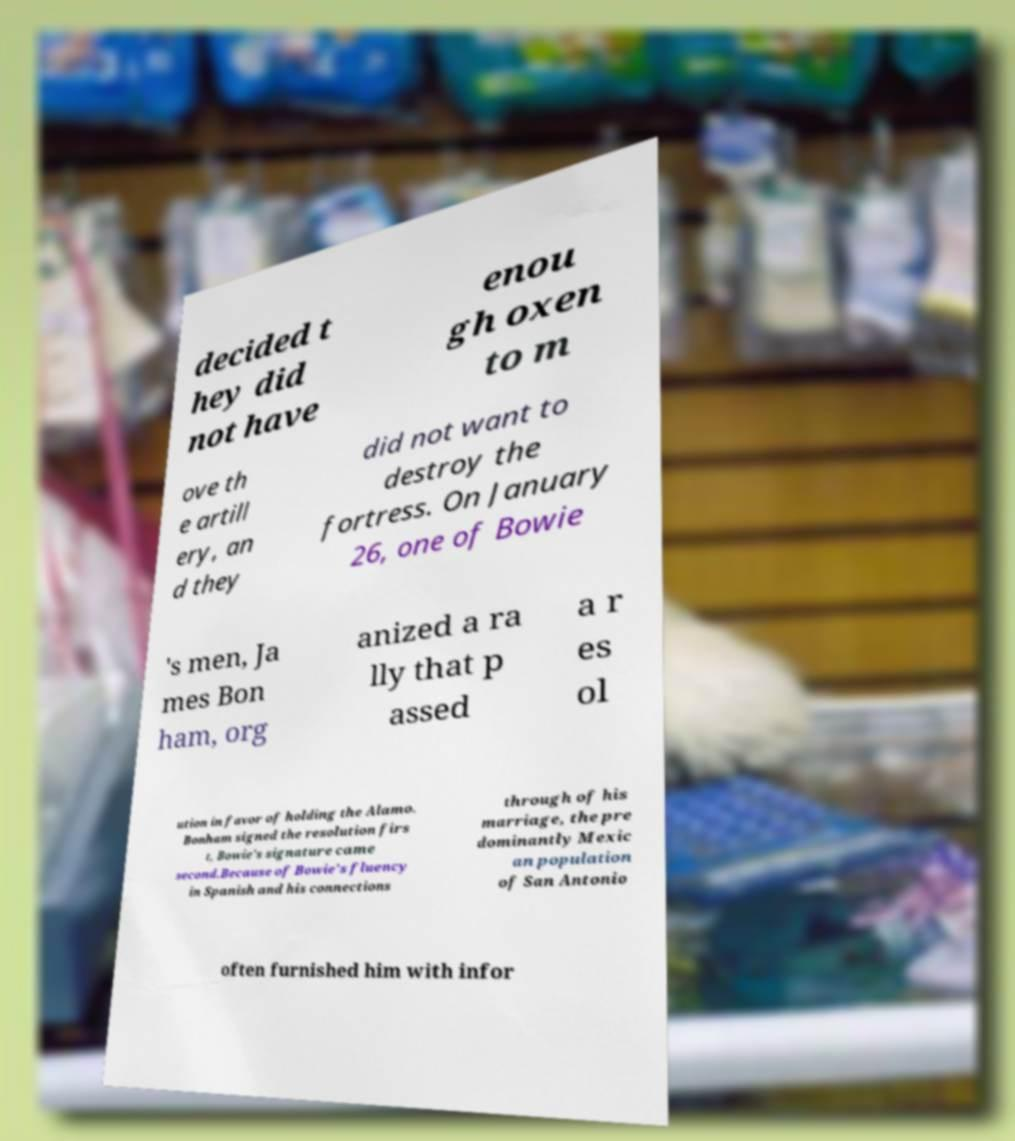Could you extract and type out the text from this image? decided t hey did not have enou gh oxen to m ove th e artill ery, an d they did not want to destroy the fortress. On January 26, one of Bowie 's men, Ja mes Bon ham, org anized a ra lly that p assed a r es ol ution in favor of holding the Alamo. Bonham signed the resolution firs t, Bowie's signature came second.Because of Bowie's fluency in Spanish and his connections through of his marriage, the pre dominantly Mexic an population of San Antonio often furnished him with infor 